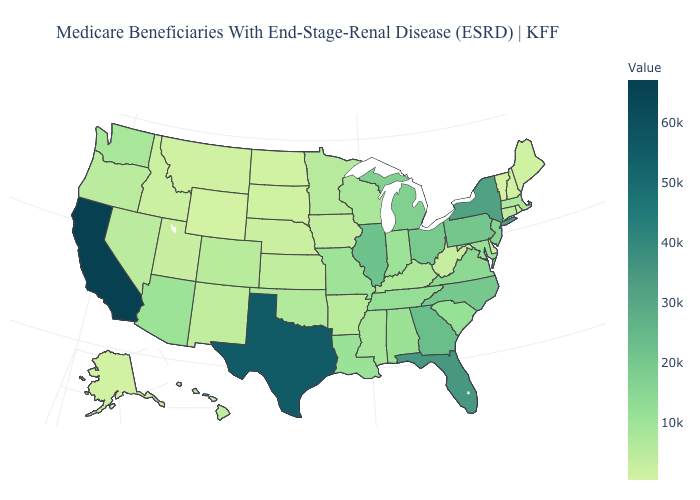Does Illinois have the highest value in the MidWest?
Keep it brief. Yes. Does California have the highest value in the West?
Short answer required. Yes. Does Alaska have the lowest value in the West?
Quick response, please. No. Does Oregon have the lowest value in the West?
Give a very brief answer. No. Is the legend a continuous bar?
Keep it brief. Yes. Which states hav the highest value in the Northeast?
Quick response, please. New York. 